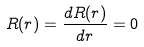Convert formula to latex. <formula><loc_0><loc_0><loc_500><loc_500>R ( r ) = \frac { d R ( r ) } { d r } = 0</formula> 